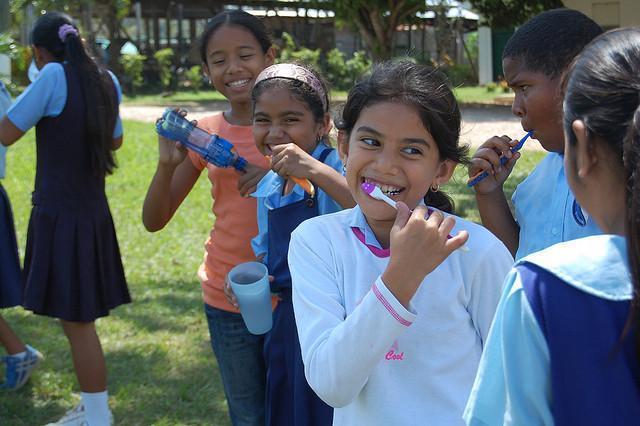How many people are there?
Give a very brief answer. 6. How many sheep are in the picture?
Give a very brief answer. 0. 